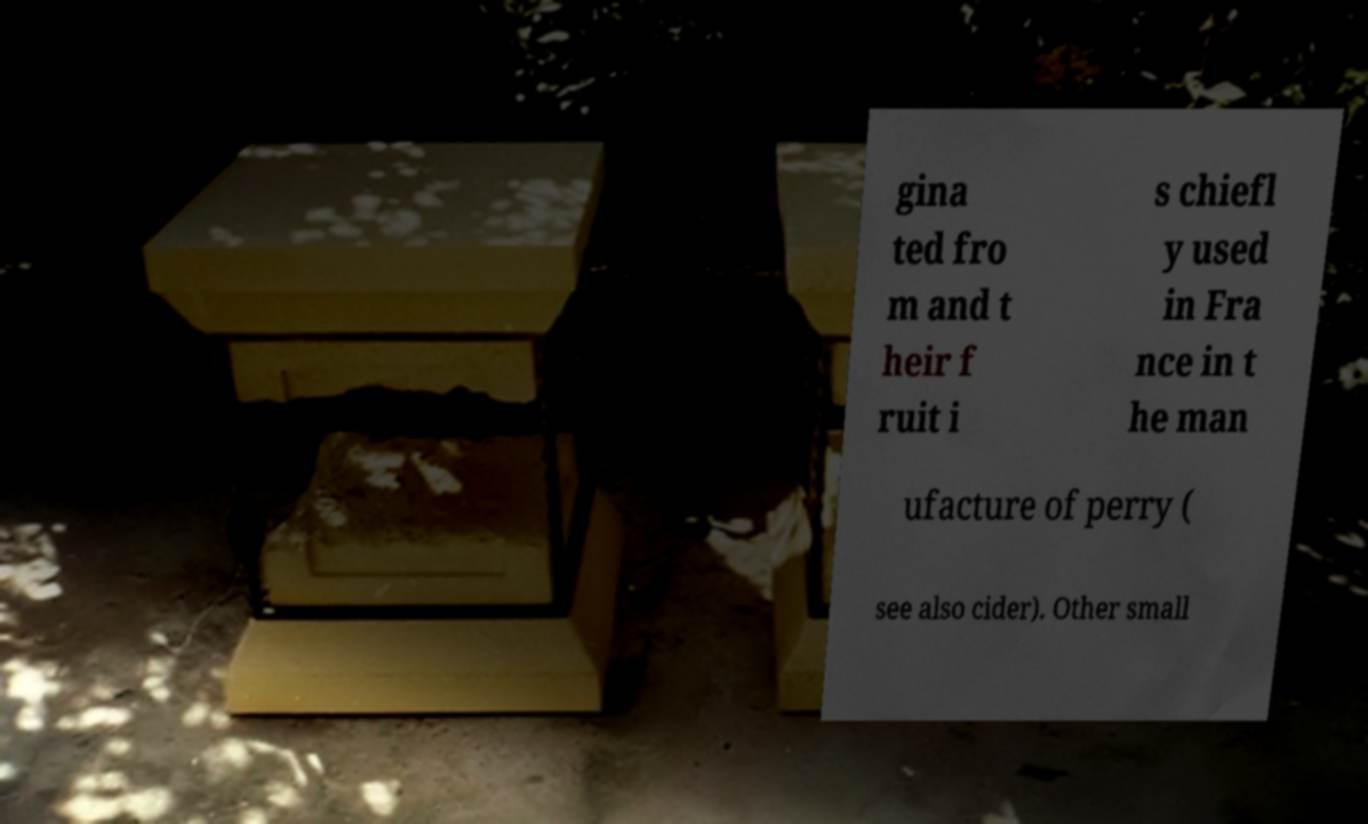Can you accurately transcribe the text from the provided image for me? gina ted fro m and t heir f ruit i s chiefl y used in Fra nce in t he man ufacture of perry ( see also cider). Other small 